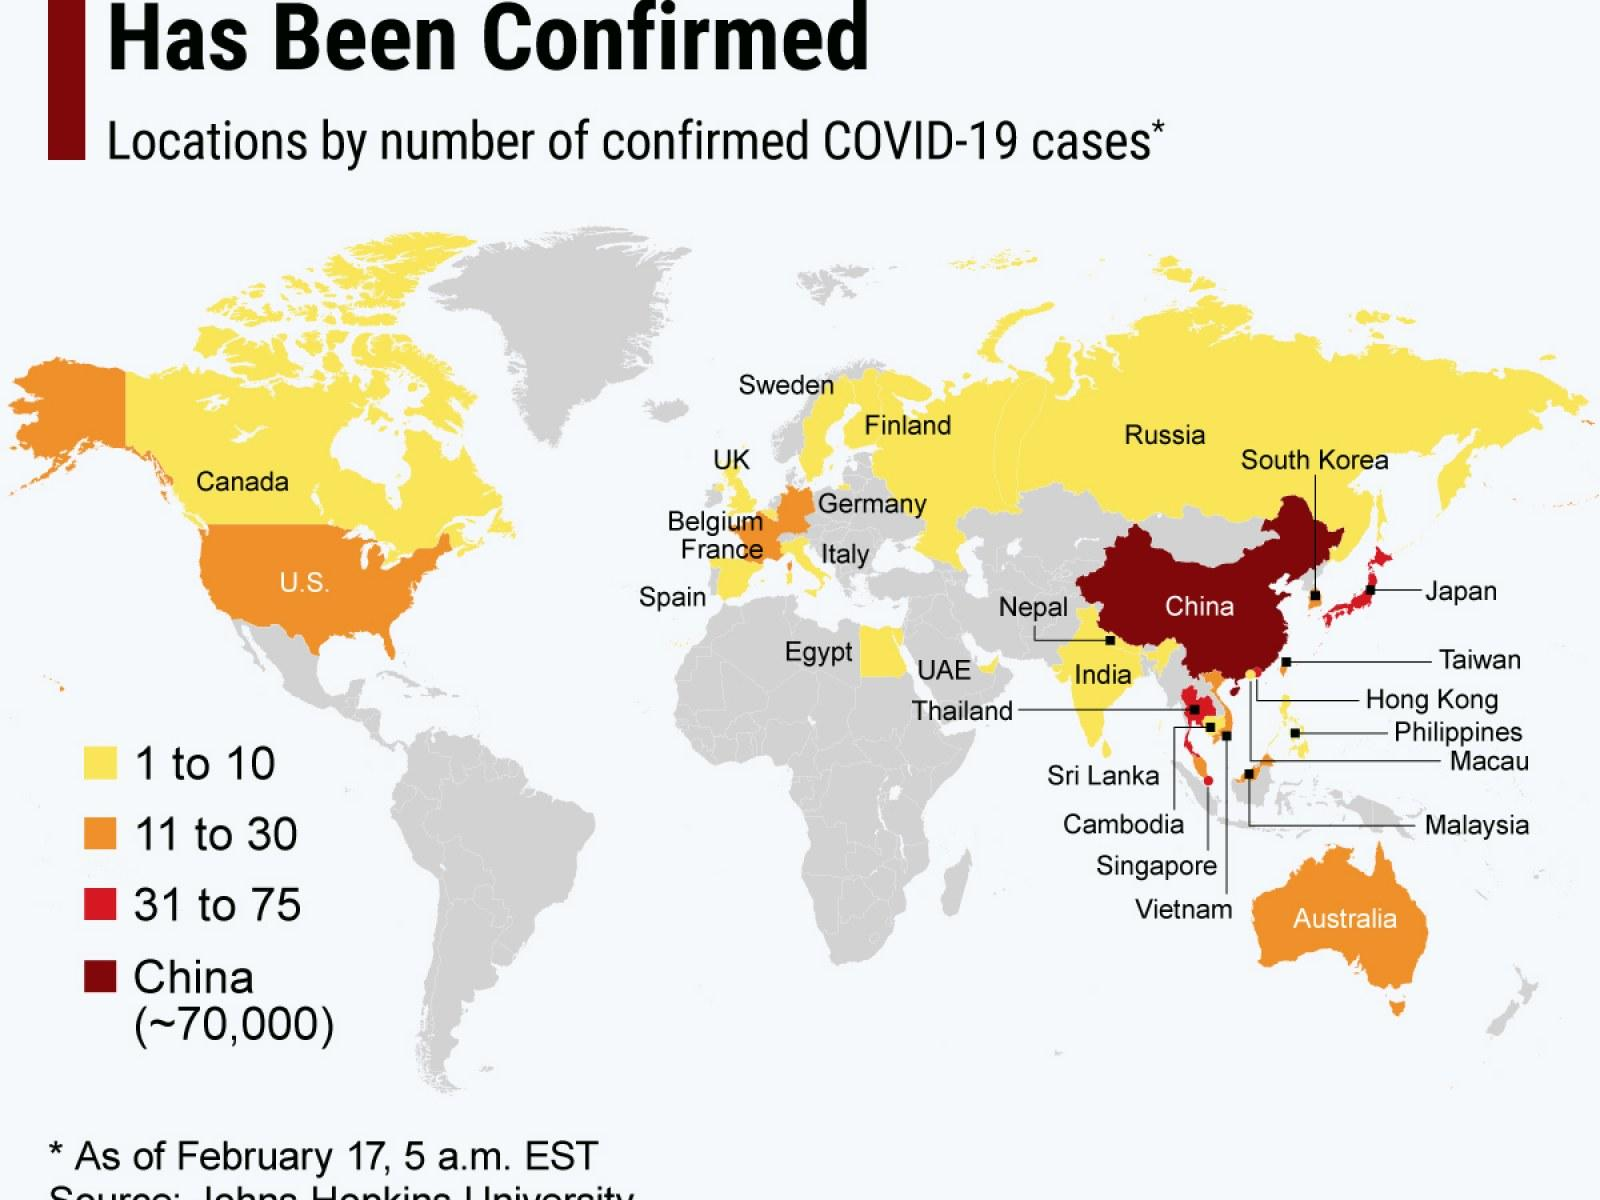Point out several critical features in this image. The UAE has reported fewer COVID-19 cases than China and Australia. According to reported data, Thailand has the highest number of COVID-19 cases among Thailand, Philippines, and Malaysia. The country with more reported COVID-19 cases among the US and Sweden is... The number of confirmed cases of COVID-19 in Canada is currently at 1 to 10. Australia has reported more COVID-19 cases than India and the UAE. 